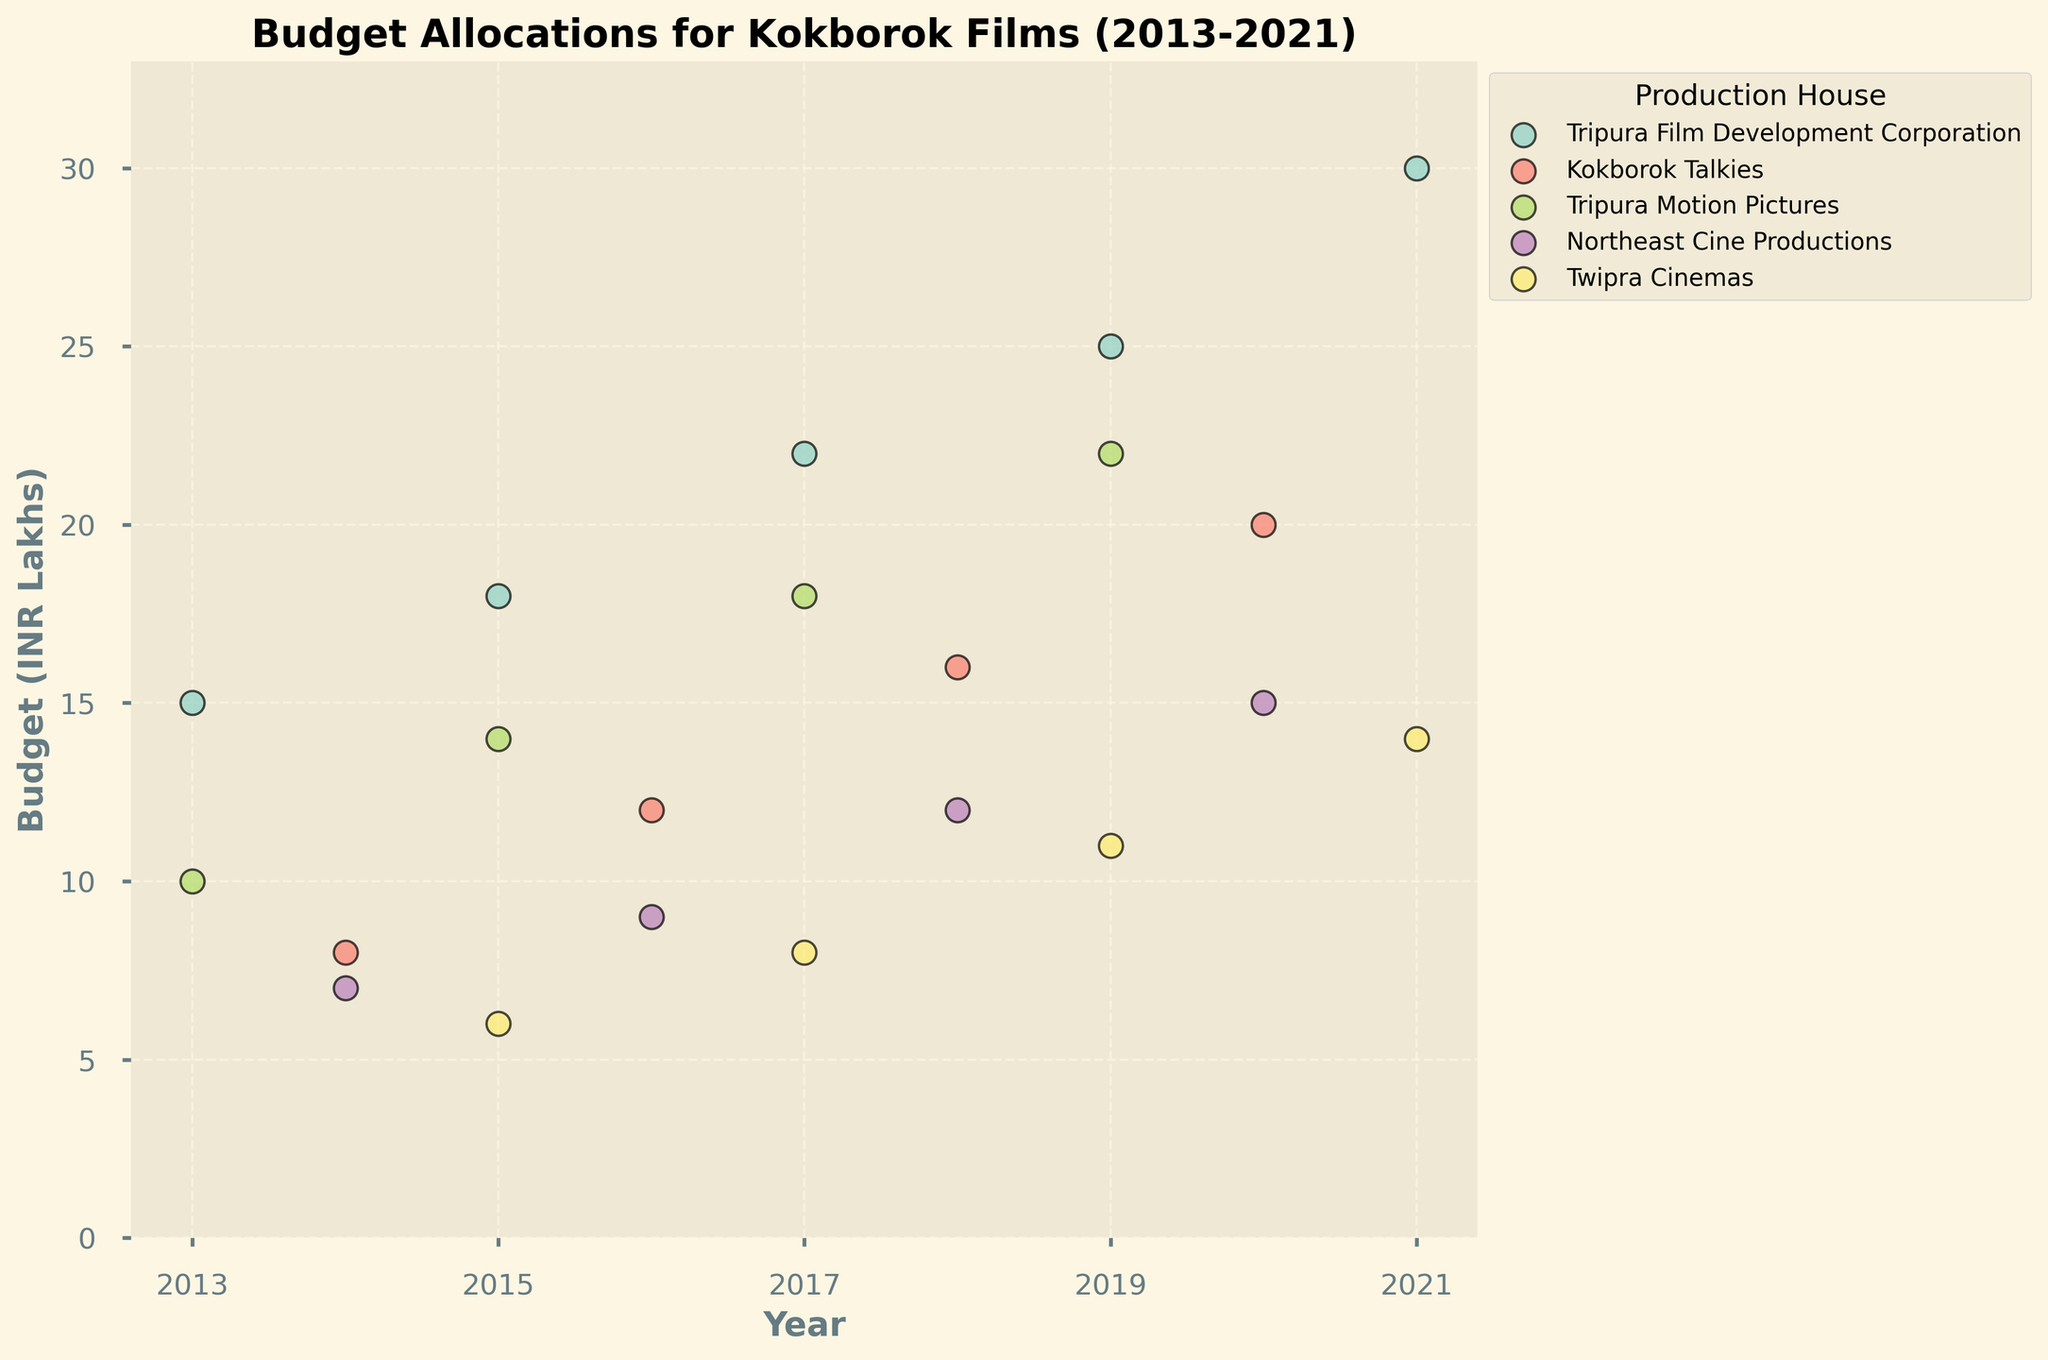What is the title of the figure? Look at the top of the figure where the title is displayed.
Answer: Budget Allocations for Kokborok Films (2013-2021) What is the range of budget allocations displayed on the y-axis? Examine the labels on the y-axis to identify the lowest and highest values.
Answer: 0 to 33 INR Lakhs Which production house had the highest budget allocation in 2021? Identify the dots corresponding to the year 2021 and observe which production house has the highest position on the y-axis.
Answer: Tripura Film Development Corporation How many production houses are represented in the figure? Count the different production house labels in the legend or look at the distinct colors/dots in the plot.
Answer: 5 Which production house shows a consistent increase in budget allocation over every recorded year? Examine the trends of budget allocations over the years for each production house and identify the one with a continuous upward trend.
Answer: Tripura Film Development Corporation In which year did Kokborok Talkies have a budget of 20 INR Lakhs? Locate the point in the Kokborok Talkies data series (color-coded) that aligns with a y-value of 20 INR Lakhs and check the corresponding x-axis (year).
Answer: 2020 What is the total budget allocation for Northeast Cine Productions from 2014 to 2020? Add the budgets for the years 2014, 2016, 2018, and 2020 under Northeast Cine Productions.
Answer: 43 INR Lakhs Which production house had the lowest budget allocation in 2015? Look at the points corresponding to the year 2015 and determine which one is at the lowest position on the y-axis.
Answer: Twipra Cinemas Compare the budget allocations of Tripura Motion Pictures and Northeast Cine Productions in 2018. Which one is higher? Find the points in the plot corresponding to 2018 for both production houses and compare their y-axis values.
Answer: Tripura Motion Pictures How do the budget allocations of Tripura Film Development Corporation in 2013 and 2021 compare? Locate the points for Tripura Film Development Corporation in 2013 and 2021 and compare their y-axis values.
Answer: 2021 budget is higher 